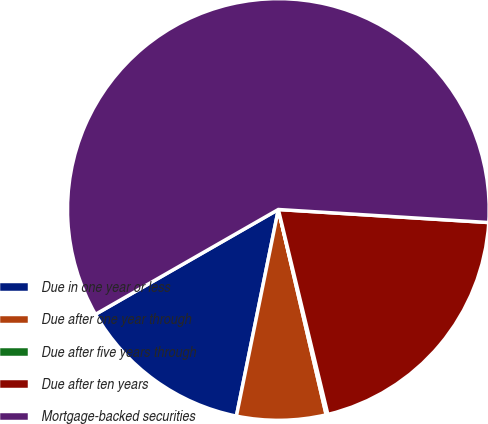<chart> <loc_0><loc_0><loc_500><loc_500><pie_chart><fcel>Due in one year or less<fcel>Due after one year through<fcel>Due after five years through<fcel>Due after ten years<fcel>Mortgage-backed securities<nl><fcel>13.53%<fcel>6.83%<fcel>0.13%<fcel>20.24%<fcel>59.27%<nl></chart> 